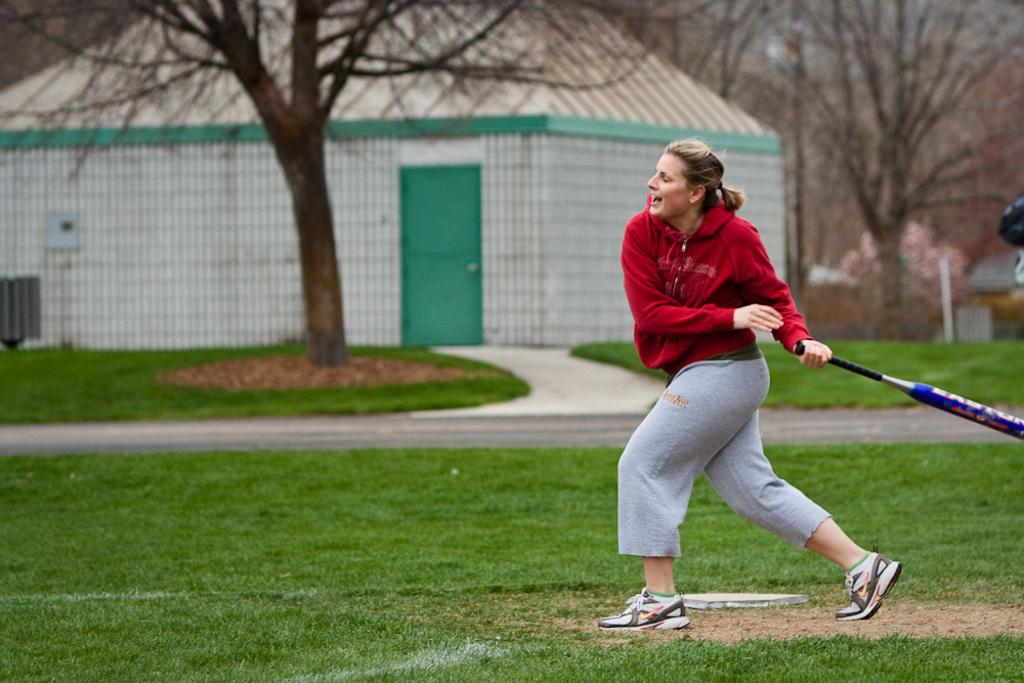What type of vegetation can be seen in the image? There is grass in the image. What is the woman in the image doing? The woman is standing on the grass and holding a bat. What can be seen in the background of the image? There is a building, trees, and a path visible in the background of the image. How many sheep are grazing on the celery in the image? There are no sheep or celery present in the image. What type of trip is the woman planning to take with her bat in the image? There is no indication of a trip or any travel-related activity in the image. 